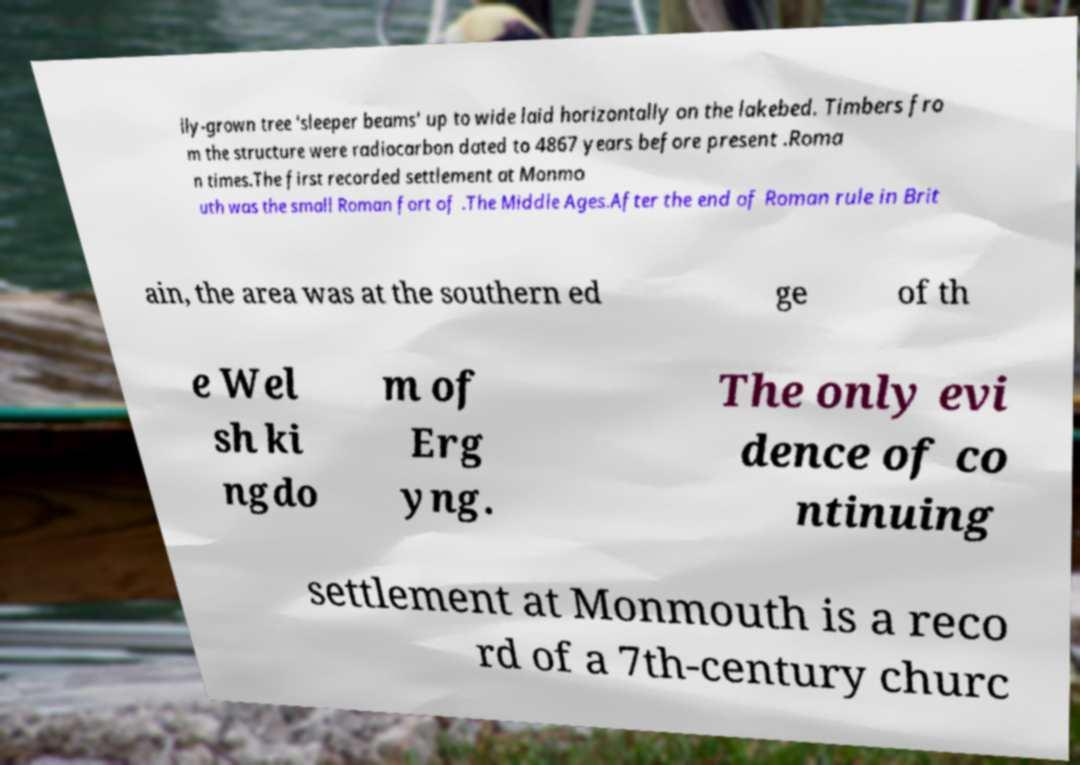What messages or text are displayed in this image? I need them in a readable, typed format. lly-grown tree 'sleeper beams' up to wide laid horizontally on the lakebed. Timbers fro m the structure were radiocarbon dated to 4867 years before present .Roma n times.The first recorded settlement at Monmo uth was the small Roman fort of .The Middle Ages.After the end of Roman rule in Brit ain, the area was at the southern ed ge of th e Wel sh ki ngdo m of Erg yng. The only evi dence of co ntinuing settlement at Monmouth is a reco rd of a 7th-century churc 